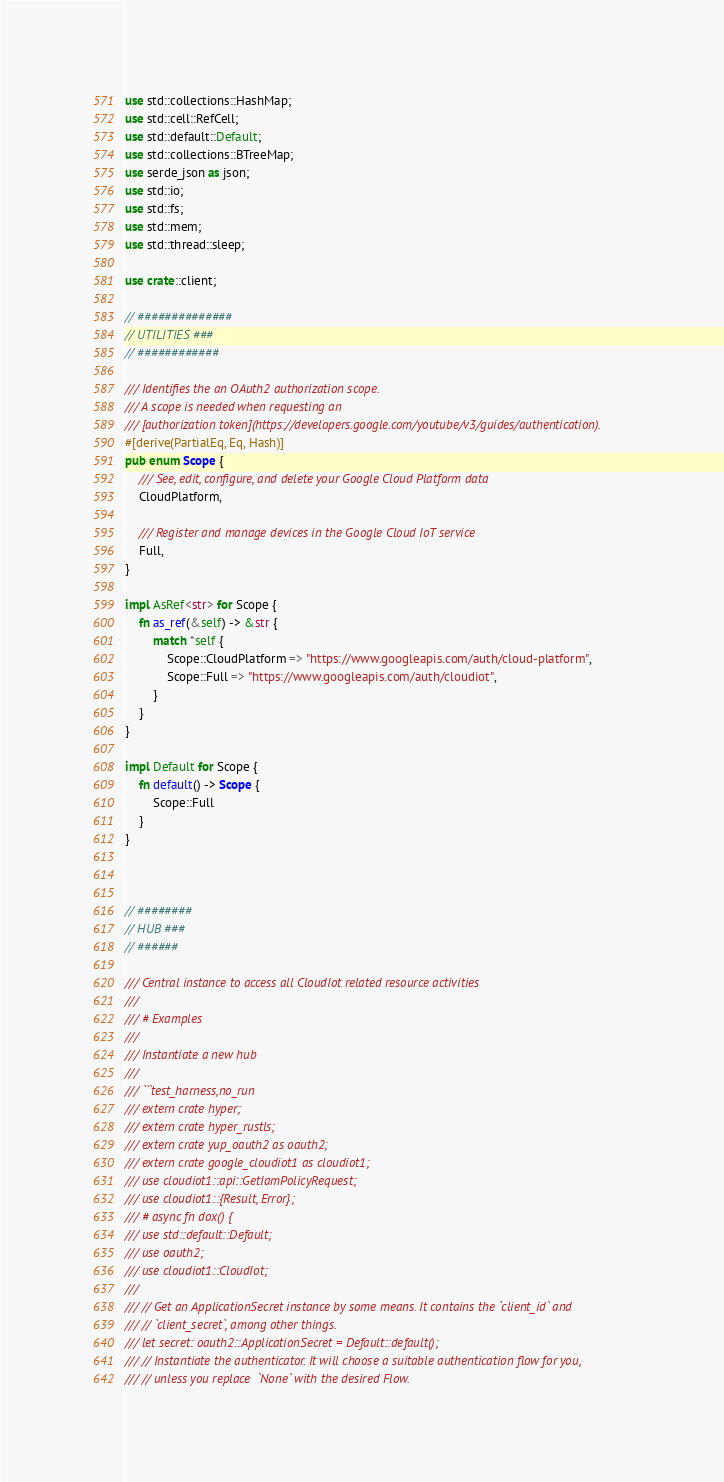Convert code to text. <code><loc_0><loc_0><loc_500><loc_500><_Rust_>use std::collections::HashMap;
use std::cell::RefCell;
use std::default::Default;
use std::collections::BTreeMap;
use serde_json as json;
use std::io;
use std::fs;
use std::mem;
use std::thread::sleep;

use crate::client;

// ##############
// UTILITIES ###
// ############

/// Identifies the an OAuth2 authorization scope.
/// A scope is needed when requesting an
/// [authorization token](https://developers.google.com/youtube/v3/guides/authentication).
#[derive(PartialEq, Eq, Hash)]
pub enum Scope {
    /// See, edit, configure, and delete your Google Cloud Platform data
    CloudPlatform,

    /// Register and manage devices in the Google Cloud IoT service
    Full,
}

impl AsRef<str> for Scope {
    fn as_ref(&self) -> &str {
        match *self {
            Scope::CloudPlatform => "https://www.googleapis.com/auth/cloud-platform",
            Scope::Full => "https://www.googleapis.com/auth/cloudiot",
        }
    }
}

impl Default for Scope {
    fn default() -> Scope {
        Scope::Full
    }
}



// ########
// HUB ###
// ######

/// Central instance to access all CloudIot related resource activities
///
/// # Examples
///
/// Instantiate a new hub
///
/// ```test_harness,no_run
/// extern crate hyper;
/// extern crate hyper_rustls;
/// extern crate yup_oauth2 as oauth2;
/// extern crate google_cloudiot1 as cloudiot1;
/// use cloudiot1::api::GetIamPolicyRequest;
/// use cloudiot1::{Result, Error};
/// # async fn dox() {
/// use std::default::Default;
/// use oauth2;
/// use cloudiot1::CloudIot;
/// 
/// // Get an ApplicationSecret instance by some means. It contains the `client_id` and 
/// // `client_secret`, among other things.
/// let secret: oauth2::ApplicationSecret = Default::default();
/// // Instantiate the authenticator. It will choose a suitable authentication flow for you, 
/// // unless you replace  `None` with the desired Flow.</code> 